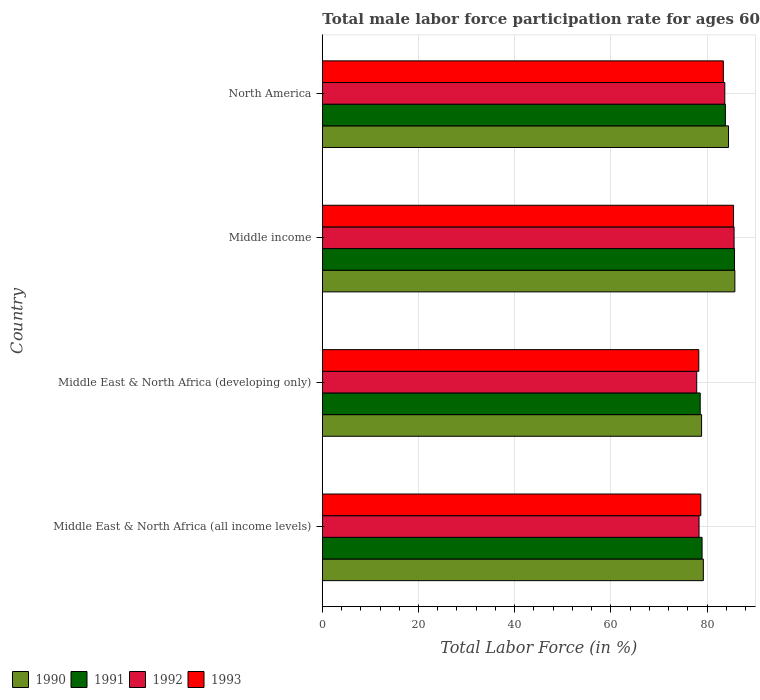How many groups of bars are there?
Offer a terse response. 4. Are the number of bars per tick equal to the number of legend labels?
Make the answer very short. Yes. How many bars are there on the 4th tick from the bottom?
Give a very brief answer. 4. What is the label of the 3rd group of bars from the top?
Make the answer very short. Middle East & North Africa (developing only). In how many cases, is the number of bars for a given country not equal to the number of legend labels?
Your answer should be very brief. 0. What is the male labor force participation rate in 1992 in Middle income?
Make the answer very short. 85.62. Across all countries, what is the maximum male labor force participation rate in 1990?
Give a very brief answer. 85.78. Across all countries, what is the minimum male labor force participation rate in 1990?
Keep it short and to the point. 78.86. In which country was the male labor force participation rate in 1991 maximum?
Offer a very short reply. Middle income. In which country was the male labor force participation rate in 1991 minimum?
Your answer should be compact. Middle East & North Africa (developing only). What is the total male labor force participation rate in 1993 in the graph?
Your answer should be very brief. 325.87. What is the difference between the male labor force participation rate in 1992 in Middle East & North Africa (all income levels) and that in Middle income?
Your answer should be compact. -7.29. What is the difference between the male labor force participation rate in 1992 in Middle income and the male labor force participation rate in 1991 in Middle East & North Africa (developing only)?
Offer a very short reply. 7.04. What is the average male labor force participation rate in 1992 per country?
Your answer should be very brief. 81.37. What is the difference between the male labor force participation rate in 1993 and male labor force participation rate in 1991 in Middle income?
Ensure brevity in your answer.  -0.2. What is the ratio of the male labor force participation rate in 1993 in Middle East & North Africa (all income levels) to that in North America?
Keep it short and to the point. 0.94. Is the difference between the male labor force participation rate in 1993 in Middle East & North Africa (developing only) and Middle income greater than the difference between the male labor force participation rate in 1991 in Middle East & North Africa (developing only) and Middle income?
Provide a succinct answer. No. What is the difference between the highest and the second highest male labor force participation rate in 1992?
Make the answer very short. 1.93. What is the difference between the highest and the lowest male labor force participation rate in 1991?
Make the answer very short. 7.13. Is it the case that in every country, the sum of the male labor force participation rate in 1993 and male labor force participation rate in 1990 is greater than the sum of male labor force participation rate in 1991 and male labor force participation rate in 1992?
Ensure brevity in your answer.  No. What does the 3rd bar from the bottom in Middle income represents?
Give a very brief answer. 1992. How many countries are there in the graph?
Ensure brevity in your answer.  4. What is the difference between two consecutive major ticks on the X-axis?
Provide a succinct answer. 20. Are the values on the major ticks of X-axis written in scientific E-notation?
Ensure brevity in your answer.  No. Where does the legend appear in the graph?
Keep it short and to the point. Bottom left. How many legend labels are there?
Your answer should be compact. 4. How are the legend labels stacked?
Provide a succinct answer. Horizontal. What is the title of the graph?
Your answer should be very brief. Total male labor force participation rate for ages 60+. Does "1991" appear as one of the legend labels in the graph?
Provide a succinct answer. Yes. What is the label or title of the X-axis?
Your answer should be very brief. Total Labor Force (in %). What is the label or title of the Y-axis?
Offer a terse response. Country. What is the Total Labor Force (in %) in 1990 in Middle East & North Africa (all income levels)?
Give a very brief answer. 79.22. What is the Total Labor Force (in %) of 1991 in Middle East & North Africa (all income levels)?
Your answer should be very brief. 78.96. What is the Total Labor Force (in %) of 1992 in Middle East & North Africa (all income levels)?
Your response must be concise. 78.33. What is the Total Labor Force (in %) of 1993 in Middle East & North Africa (all income levels)?
Give a very brief answer. 78.7. What is the Total Labor Force (in %) of 1990 in Middle East & North Africa (developing only)?
Your response must be concise. 78.86. What is the Total Labor Force (in %) in 1991 in Middle East & North Africa (developing only)?
Offer a terse response. 78.57. What is the Total Labor Force (in %) of 1992 in Middle East & North Africa (developing only)?
Ensure brevity in your answer.  77.85. What is the Total Labor Force (in %) in 1993 in Middle East & North Africa (developing only)?
Offer a very short reply. 78.28. What is the Total Labor Force (in %) of 1990 in Middle income?
Provide a short and direct response. 85.78. What is the Total Labor Force (in %) in 1991 in Middle income?
Provide a short and direct response. 85.71. What is the Total Labor Force (in %) of 1992 in Middle income?
Provide a short and direct response. 85.62. What is the Total Labor Force (in %) of 1993 in Middle income?
Ensure brevity in your answer.  85.5. What is the Total Labor Force (in %) of 1990 in North America?
Offer a terse response. 84.45. What is the Total Labor Force (in %) of 1991 in North America?
Provide a succinct answer. 83.81. What is the Total Labor Force (in %) of 1992 in North America?
Keep it short and to the point. 83.69. What is the Total Labor Force (in %) in 1993 in North America?
Provide a succinct answer. 83.39. Across all countries, what is the maximum Total Labor Force (in %) in 1990?
Offer a very short reply. 85.78. Across all countries, what is the maximum Total Labor Force (in %) of 1991?
Provide a short and direct response. 85.71. Across all countries, what is the maximum Total Labor Force (in %) in 1992?
Ensure brevity in your answer.  85.62. Across all countries, what is the maximum Total Labor Force (in %) in 1993?
Make the answer very short. 85.5. Across all countries, what is the minimum Total Labor Force (in %) of 1990?
Keep it short and to the point. 78.86. Across all countries, what is the minimum Total Labor Force (in %) in 1991?
Offer a terse response. 78.57. Across all countries, what is the minimum Total Labor Force (in %) in 1992?
Your answer should be compact. 77.85. Across all countries, what is the minimum Total Labor Force (in %) in 1993?
Provide a succinct answer. 78.28. What is the total Total Labor Force (in %) in 1990 in the graph?
Your response must be concise. 328.31. What is the total Total Labor Force (in %) in 1991 in the graph?
Make the answer very short. 327.05. What is the total Total Labor Force (in %) of 1992 in the graph?
Your answer should be very brief. 325.48. What is the total Total Labor Force (in %) in 1993 in the graph?
Offer a very short reply. 325.87. What is the difference between the Total Labor Force (in %) of 1990 in Middle East & North Africa (all income levels) and that in Middle East & North Africa (developing only)?
Give a very brief answer. 0.37. What is the difference between the Total Labor Force (in %) in 1991 in Middle East & North Africa (all income levels) and that in Middle East & North Africa (developing only)?
Give a very brief answer. 0.39. What is the difference between the Total Labor Force (in %) of 1992 in Middle East & North Africa (all income levels) and that in Middle East & North Africa (developing only)?
Provide a short and direct response. 0.48. What is the difference between the Total Labor Force (in %) of 1993 in Middle East & North Africa (all income levels) and that in Middle East & North Africa (developing only)?
Make the answer very short. 0.42. What is the difference between the Total Labor Force (in %) of 1990 in Middle East & North Africa (all income levels) and that in Middle income?
Provide a short and direct response. -6.55. What is the difference between the Total Labor Force (in %) in 1991 in Middle East & North Africa (all income levels) and that in Middle income?
Your answer should be very brief. -6.74. What is the difference between the Total Labor Force (in %) in 1992 in Middle East & North Africa (all income levels) and that in Middle income?
Provide a succinct answer. -7.29. What is the difference between the Total Labor Force (in %) in 1993 in Middle East & North Africa (all income levels) and that in Middle income?
Your answer should be compact. -6.81. What is the difference between the Total Labor Force (in %) of 1990 in Middle East & North Africa (all income levels) and that in North America?
Keep it short and to the point. -5.23. What is the difference between the Total Labor Force (in %) in 1991 in Middle East & North Africa (all income levels) and that in North America?
Your answer should be compact. -4.85. What is the difference between the Total Labor Force (in %) in 1992 in Middle East & North Africa (all income levels) and that in North America?
Keep it short and to the point. -5.36. What is the difference between the Total Labor Force (in %) of 1993 in Middle East & North Africa (all income levels) and that in North America?
Make the answer very short. -4.69. What is the difference between the Total Labor Force (in %) of 1990 in Middle East & North Africa (developing only) and that in Middle income?
Keep it short and to the point. -6.92. What is the difference between the Total Labor Force (in %) of 1991 in Middle East & North Africa (developing only) and that in Middle income?
Keep it short and to the point. -7.13. What is the difference between the Total Labor Force (in %) in 1992 in Middle East & North Africa (developing only) and that in Middle income?
Your response must be concise. -7.77. What is the difference between the Total Labor Force (in %) of 1993 in Middle East & North Africa (developing only) and that in Middle income?
Give a very brief answer. -7.23. What is the difference between the Total Labor Force (in %) in 1990 in Middle East & North Africa (developing only) and that in North America?
Ensure brevity in your answer.  -5.59. What is the difference between the Total Labor Force (in %) in 1991 in Middle East & North Africa (developing only) and that in North America?
Your answer should be very brief. -5.24. What is the difference between the Total Labor Force (in %) of 1992 in Middle East & North Africa (developing only) and that in North America?
Ensure brevity in your answer.  -5.84. What is the difference between the Total Labor Force (in %) of 1993 in Middle East & North Africa (developing only) and that in North America?
Provide a short and direct response. -5.11. What is the difference between the Total Labor Force (in %) of 1990 in Middle income and that in North America?
Your response must be concise. 1.33. What is the difference between the Total Labor Force (in %) in 1991 in Middle income and that in North America?
Make the answer very short. 1.9. What is the difference between the Total Labor Force (in %) in 1992 in Middle income and that in North America?
Provide a succinct answer. 1.93. What is the difference between the Total Labor Force (in %) of 1993 in Middle income and that in North America?
Ensure brevity in your answer.  2.12. What is the difference between the Total Labor Force (in %) in 1990 in Middle East & North Africa (all income levels) and the Total Labor Force (in %) in 1991 in Middle East & North Africa (developing only)?
Your answer should be compact. 0.65. What is the difference between the Total Labor Force (in %) of 1990 in Middle East & North Africa (all income levels) and the Total Labor Force (in %) of 1992 in Middle East & North Africa (developing only)?
Make the answer very short. 1.38. What is the difference between the Total Labor Force (in %) in 1990 in Middle East & North Africa (all income levels) and the Total Labor Force (in %) in 1993 in Middle East & North Africa (developing only)?
Offer a terse response. 0.94. What is the difference between the Total Labor Force (in %) of 1991 in Middle East & North Africa (all income levels) and the Total Labor Force (in %) of 1992 in Middle East & North Africa (developing only)?
Keep it short and to the point. 1.12. What is the difference between the Total Labor Force (in %) of 1991 in Middle East & North Africa (all income levels) and the Total Labor Force (in %) of 1993 in Middle East & North Africa (developing only)?
Your answer should be compact. 0.68. What is the difference between the Total Labor Force (in %) of 1992 in Middle East & North Africa (all income levels) and the Total Labor Force (in %) of 1993 in Middle East & North Africa (developing only)?
Give a very brief answer. 0.05. What is the difference between the Total Labor Force (in %) in 1990 in Middle East & North Africa (all income levels) and the Total Labor Force (in %) in 1991 in Middle income?
Make the answer very short. -6.48. What is the difference between the Total Labor Force (in %) of 1990 in Middle East & North Africa (all income levels) and the Total Labor Force (in %) of 1992 in Middle income?
Provide a succinct answer. -6.39. What is the difference between the Total Labor Force (in %) of 1990 in Middle East & North Africa (all income levels) and the Total Labor Force (in %) of 1993 in Middle income?
Make the answer very short. -6.28. What is the difference between the Total Labor Force (in %) of 1991 in Middle East & North Africa (all income levels) and the Total Labor Force (in %) of 1992 in Middle income?
Provide a short and direct response. -6.65. What is the difference between the Total Labor Force (in %) of 1991 in Middle East & North Africa (all income levels) and the Total Labor Force (in %) of 1993 in Middle income?
Your answer should be very brief. -6.54. What is the difference between the Total Labor Force (in %) of 1992 in Middle East & North Africa (all income levels) and the Total Labor Force (in %) of 1993 in Middle income?
Provide a succinct answer. -7.17. What is the difference between the Total Labor Force (in %) of 1990 in Middle East & North Africa (all income levels) and the Total Labor Force (in %) of 1991 in North America?
Provide a short and direct response. -4.59. What is the difference between the Total Labor Force (in %) of 1990 in Middle East & North Africa (all income levels) and the Total Labor Force (in %) of 1992 in North America?
Your response must be concise. -4.46. What is the difference between the Total Labor Force (in %) in 1990 in Middle East & North Africa (all income levels) and the Total Labor Force (in %) in 1993 in North America?
Give a very brief answer. -4.16. What is the difference between the Total Labor Force (in %) in 1991 in Middle East & North Africa (all income levels) and the Total Labor Force (in %) in 1992 in North America?
Your response must be concise. -4.72. What is the difference between the Total Labor Force (in %) of 1991 in Middle East & North Africa (all income levels) and the Total Labor Force (in %) of 1993 in North America?
Offer a very short reply. -4.42. What is the difference between the Total Labor Force (in %) in 1992 in Middle East & North Africa (all income levels) and the Total Labor Force (in %) in 1993 in North America?
Keep it short and to the point. -5.06. What is the difference between the Total Labor Force (in %) of 1990 in Middle East & North Africa (developing only) and the Total Labor Force (in %) of 1991 in Middle income?
Make the answer very short. -6.85. What is the difference between the Total Labor Force (in %) in 1990 in Middle East & North Africa (developing only) and the Total Labor Force (in %) in 1992 in Middle income?
Your answer should be very brief. -6.76. What is the difference between the Total Labor Force (in %) in 1990 in Middle East & North Africa (developing only) and the Total Labor Force (in %) in 1993 in Middle income?
Keep it short and to the point. -6.65. What is the difference between the Total Labor Force (in %) of 1991 in Middle East & North Africa (developing only) and the Total Labor Force (in %) of 1992 in Middle income?
Provide a short and direct response. -7.04. What is the difference between the Total Labor Force (in %) in 1991 in Middle East & North Africa (developing only) and the Total Labor Force (in %) in 1993 in Middle income?
Make the answer very short. -6.93. What is the difference between the Total Labor Force (in %) in 1992 in Middle East & North Africa (developing only) and the Total Labor Force (in %) in 1993 in Middle income?
Ensure brevity in your answer.  -7.66. What is the difference between the Total Labor Force (in %) of 1990 in Middle East & North Africa (developing only) and the Total Labor Force (in %) of 1991 in North America?
Give a very brief answer. -4.95. What is the difference between the Total Labor Force (in %) in 1990 in Middle East & North Africa (developing only) and the Total Labor Force (in %) in 1992 in North America?
Give a very brief answer. -4.83. What is the difference between the Total Labor Force (in %) in 1990 in Middle East & North Africa (developing only) and the Total Labor Force (in %) in 1993 in North America?
Your response must be concise. -4.53. What is the difference between the Total Labor Force (in %) of 1991 in Middle East & North Africa (developing only) and the Total Labor Force (in %) of 1992 in North America?
Ensure brevity in your answer.  -5.11. What is the difference between the Total Labor Force (in %) of 1991 in Middle East & North Africa (developing only) and the Total Labor Force (in %) of 1993 in North America?
Ensure brevity in your answer.  -4.81. What is the difference between the Total Labor Force (in %) of 1992 in Middle East & North Africa (developing only) and the Total Labor Force (in %) of 1993 in North America?
Ensure brevity in your answer.  -5.54. What is the difference between the Total Labor Force (in %) of 1990 in Middle income and the Total Labor Force (in %) of 1991 in North America?
Give a very brief answer. 1.97. What is the difference between the Total Labor Force (in %) of 1990 in Middle income and the Total Labor Force (in %) of 1992 in North America?
Ensure brevity in your answer.  2.09. What is the difference between the Total Labor Force (in %) in 1990 in Middle income and the Total Labor Force (in %) in 1993 in North America?
Offer a very short reply. 2.39. What is the difference between the Total Labor Force (in %) in 1991 in Middle income and the Total Labor Force (in %) in 1992 in North America?
Provide a short and direct response. 2.02. What is the difference between the Total Labor Force (in %) in 1991 in Middle income and the Total Labor Force (in %) in 1993 in North America?
Make the answer very short. 2.32. What is the difference between the Total Labor Force (in %) in 1992 in Middle income and the Total Labor Force (in %) in 1993 in North America?
Offer a very short reply. 2.23. What is the average Total Labor Force (in %) in 1990 per country?
Keep it short and to the point. 82.08. What is the average Total Labor Force (in %) in 1991 per country?
Your answer should be very brief. 81.76. What is the average Total Labor Force (in %) in 1992 per country?
Provide a succinct answer. 81.37. What is the average Total Labor Force (in %) in 1993 per country?
Keep it short and to the point. 81.47. What is the difference between the Total Labor Force (in %) in 1990 and Total Labor Force (in %) in 1991 in Middle East & North Africa (all income levels)?
Your answer should be very brief. 0.26. What is the difference between the Total Labor Force (in %) in 1990 and Total Labor Force (in %) in 1992 in Middle East & North Africa (all income levels)?
Make the answer very short. 0.89. What is the difference between the Total Labor Force (in %) in 1990 and Total Labor Force (in %) in 1993 in Middle East & North Africa (all income levels)?
Give a very brief answer. 0.53. What is the difference between the Total Labor Force (in %) of 1991 and Total Labor Force (in %) of 1992 in Middle East & North Africa (all income levels)?
Give a very brief answer. 0.63. What is the difference between the Total Labor Force (in %) in 1991 and Total Labor Force (in %) in 1993 in Middle East & North Africa (all income levels)?
Ensure brevity in your answer.  0.27. What is the difference between the Total Labor Force (in %) of 1992 and Total Labor Force (in %) of 1993 in Middle East & North Africa (all income levels)?
Make the answer very short. -0.37. What is the difference between the Total Labor Force (in %) of 1990 and Total Labor Force (in %) of 1991 in Middle East & North Africa (developing only)?
Offer a terse response. 0.29. What is the difference between the Total Labor Force (in %) in 1990 and Total Labor Force (in %) in 1992 in Middle East & North Africa (developing only)?
Offer a very short reply. 1.01. What is the difference between the Total Labor Force (in %) in 1990 and Total Labor Force (in %) in 1993 in Middle East & North Africa (developing only)?
Provide a succinct answer. 0.58. What is the difference between the Total Labor Force (in %) of 1991 and Total Labor Force (in %) of 1992 in Middle East & North Africa (developing only)?
Ensure brevity in your answer.  0.73. What is the difference between the Total Labor Force (in %) of 1991 and Total Labor Force (in %) of 1993 in Middle East & North Africa (developing only)?
Your response must be concise. 0.29. What is the difference between the Total Labor Force (in %) in 1992 and Total Labor Force (in %) in 1993 in Middle East & North Africa (developing only)?
Make the answer very short. -0.43. What is the difference between the Total Labor Force (in %) of 1990 and Total Labor Force (in %) of 1991 in Middle income?
Offer a very short reply. 0.07. What is the difference between the Total Labor Force (in %) of 1990 and Total Labor Force (in %) of 1992 in Middle income?
Your answer should be very brief. 0.16. What is the difference between the Total Labor Force (in %) of 1990 and Total Labor Force (in %) of 1993 in Middle income?
Provide a succinct answer. 0.27. What is the difference between the Total Labor Force (in %) in 1991 and Total Labor Force (in %) in 1992 in Middle income?
Provide a short and direct response. 0.09. What is the difference between the Total Labor Force (in %) in 1991 and Total Labor Force (in %) in 1993 in Middle income?
Offer a very short reply. 0.2. What is the difference between the Total Labor Force (in %) of 1992 and Total Labor Force (in %) of 1993 in Middle income?
Your answer should be compact. 0.11. What is the difference between the Total Labor Force (in %) in 1990 and Total Labor Force (in %) in 1991 in North America?
Your response must be concise. 0.64. What is the difference between the Total Labor Force (in %) in 1990 and Total Labor Force (in %) in 1992 in North America?
Provide a short and direct response. 0.77. What is the difference between the Total Labor Force (in %) in 1990 and Total Labor Force (in %) in 1993 in North America?
Give a very brief answer. 1.07. What is the difference between the Total Labor Force (in %) in 1991 and Total Labor Force (in %) in 1992 in North America?
Your answer should be very brief. 0.12. What is the difference between the Total Labor Force (in %) of 1991 and Total Labor Force (in %) of 1993 in North America?
Make the answer very short. 0.42. What is the difference between the Total Labor Force (in %) of 1992 and Total Labor Force (in %) of 1993 in North America?
Offer a very short reply. 0.3. What is the ratio of the Total Labor Force (in %) of 1990 in Middle East & North Africa (all income levels) to that in Middle East & North Africa (developing only)?
Give a very brief answer. 1. What is the ratio of the Total Labor Force (in %) in 1990 in Middle East & North Africa (all income levels) to that in Middle income?
Make the answer very short. 0.92. What is the ratio of the Total Labor Force (in %) of 1991 in Middle East & North Africa (all income levels) to that in Middle income?
Make the answer very short. 0.92. What is the ratio of the Total Labor Force (in %) in 1992 in Middle East & North Africa (all income levels) to that in Middle income?
Your response must be concise. 0.91. What is the ratio of the Total Labor Force (in %) in 1993 in Middle East & North Africa (all income levels) to that in Middle income?
Keep it short and to the point. 0.92. What is the ratio of the Total Labor Force (in %) of 1990 in Middle East & North Africa (all income levels) to that in North America?
Keep it short and to the point. 0.94. What is the ratio of the Total Labor Force (in %) of 1991 in Middle East & North Africa (all income levels) to that in North America?
Provide a succinct answer. 0.94. What is the ratio of the Total Labor Force (in %) in 1992 in Middle East & North Africa (all income levels) to that in North America?
Offer a very short reply. 0.94. What is the ratio of the Total Labor Force (in %) in 1993 in Middle East & North Africa (all income levels) to that in North America?
Your answer should be very brief. 0.94. What is the ratio of the Total Labor Force (in %) in 1990 in Middle East & North Africa (developing only) to that in Middle income?
Provide a succinct answer. 0.92. What is the ratio of the Total Labor Force (in %) of 1991 in Middle East & North Africa (developing only) to that in Middle income?
Ensure brevity in your answer.  0.92. What is the ratio of the Total Labor Force (in %) in 1992 in Middle East & North Africa (developing only) to that in Middle income?
Your answer should be compact. 0.91. What is the ratio of the Total Labor Force (in %) in 1993 in Middle East & North Africa (developing only) to that in Middle income?
Keep it short and to the point. 0.92. What is the ratio of the Total Labor Force (in %) of 1990 in Middle East & North Africa (developing only) to that in North America?
Provide a succinct answer. 0.93. What is the ratio of the Total Labor Force (in %) of 1992 in Middle East & North Africa (developing only) to that in North America?
Your answer should be very brief. 0.93. What is the ratio of the Total Labor Force (in %) in 1993 in Middle East & North Africa (developing only) to that in North America?
Offer a terse response. 0.94. What is the ratio of the Total Labor Force (in %) of 1990 in Middle income to that in North America?
Your answer should be very brief. 1.02. What is the ratio of the Total Labor Force (in %) of 1991 in Middle income to that in North America?
Make the answer very short. 1.02. What is the ratio of the Total Labor Force (in %) of 1992 in Middle income to that in North America?
Your response must be concise. 1.02. What is the ratio of the Total Labor Force (in %) of 1993 in Middle income to that in North America?
Offer a terse response. 1.03. What is the difference between the highest and the second highest Total Labor Force (in %) in 1990?
Make the answer very short. 1.33. What is the difference between the highest and the second highest Total Labor Force (in %) of 1991?
Make the answer very short. 1.9. What is the difference between the highest and the second highest Total Labor Force (in %) in 1992?
Offer a terse response. 1.93. What is the difference between the highest and the second highest Total Labor Force (in %) in 1993?
Your answer should be very brief. 2.12. What is the difference between the highest and the lowest Total Labor Force (in %) of 1990?
Offer a terse response. 6.92. What is the difference between the highest and the lowest Total Labor Force (in %) in 1991?
Provide a short and direct response. 7.13. What is the difference between the highest and the lowest Total Labor Force (in %) in 1992?
Your answer should be compact. 7.77. What is the difference between the highest and the lowest Total Labor Force (in %) in 1993?
Provide a succinct answer. 7.23. 